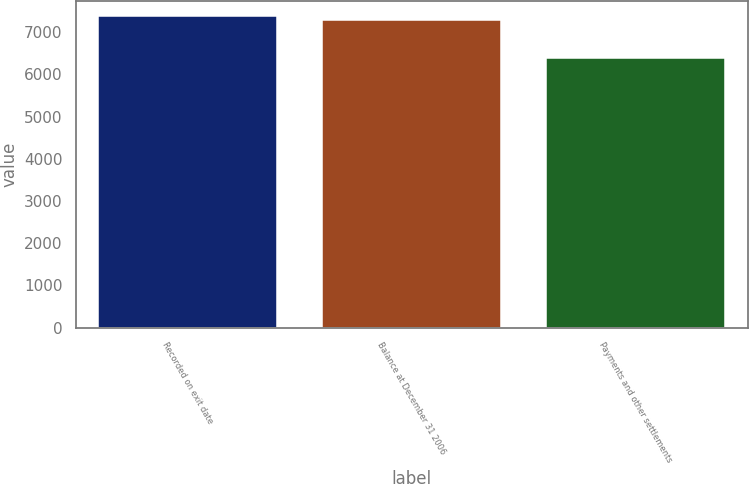<chart> <loc_0><loc_0><loc_500><loc_500><bar_chart><fcel>Recorded on exit date<fcel>Balance at December 31 2006<fcel>Payments and other settlements<nl><fcel>7368.9<fcel>7276<fcel>6390<nl></chart> 